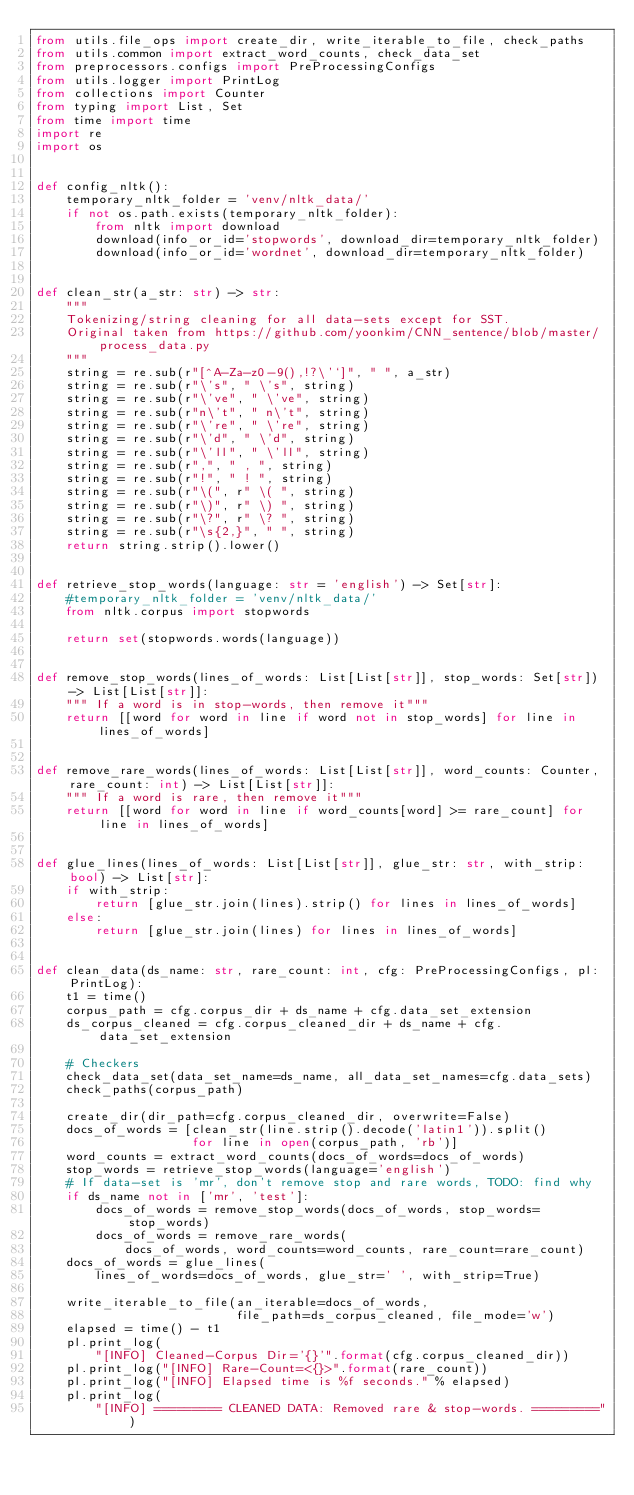Convert code to text. <code><loc_0><loc_0><loc_500><loc_500><_Python_>from utils.file_ops import create_dir, write_iterable_to_file, check_paths
from utils.common import extract_word_counts, check_data_set
from preprocessors.configs import PreProcessingConfigs
from utils.logger import PrintLog
from collections import Counter
from typing import List, Set
from time import time
import re
import os


def config_nltk():
    temporary_nltk_folder = 'venv/nltk_data/'
    if not os.path.exists(temporary_nltk_folder):
        from nltk import download
        download(info_or_id='stopwords', download_dir=temporary_nltk_folder)
        download(info_or_id='wordnet', download_dir=temporary_nltk_folder)


def clean_str(a_str: str) -> str:
    """
    Tokenizing/string cleaning for all data-sets except for SST.
    Original taken from https://github.com/yoonkim/CNN_sentence/blob/master/process_data.py
    """
    string = re.sub(r"[^A-Za-z0-9(),!?\'`]", " ", a_str)
    string = re.sub(r"\'s", " \'s", string)
    string = re.sub(r"\'ve", " \'ve", string)
    string = re.sub(r"n\'t", " n\'t", string)
    string = re.sub(r"\'re", " \'re", string)
    string = re.sub(r"\'d", " \'d", string)
    string = re.sub(r"\'ll", " \'ll", string)
    string = re.sub(r",", " , ", string)
    string = re.sub(r"!", " ! ", string)
    string = re.sub(r"\(", r" \( ", string)
    string = re.sub(r"\)", r" \) ", string)
    string = re.sub(r"\?", r" \? ", string)
    string = re.sub(r"\s{2,}", " ", string)
    return string.strip().lower()


def retrieve_stop_words(language: str = 'english') -> Set[str]:
    #temporary_nltk_folder = 'venv/nltk_data/'
    from nltk.corpus import stopwords

    return set(stopwords.words(language))


def remove_stop_words(lines_of_words: List[List[str]], stop_words: Set[str]) -> List[List[str]]:
    """ If a word is in stop-words, then remove it"""
    return [[word for word in line if word not in stop_words] for line in lines_of_words]


def remove_rare_words(lines_of_words: List[List[str]], word_counts: Counter, rare_count: int) -> List[List[str]]:
    """ If a word is rare, then remove it"""
    return [[word for word in line if word_counts[word] >= rare_count] for line in lines_of_words]


def glue_lines(lines_of_words: List[List[str]], glue_str: str, with_strip: bool) -> List[str]:
    if with_strip:
        return [glue_str.join(lines).strip() for lines in lines_of_words]
    else:
        return [glue_str.join(lines) for lines in lines_of_words]


def clean_data(ds_name: str, rare_count: int, cfg: PreProcessingConfigs, pl: PrintLog):
    t1 = time()
    corpus_path = cfg.corpus_dir + ds_name + cfg.data_set_extension
    ds_corpus_cleaned = cfg.corpus_cleaned_dir + ds_name + cfg.data_set_extension

    # Checkers
    check_data_set(data_set_name=ds_name, all_data_set_names=cfg.data_sets)
    check_paths(corpus_path)

    create_dir(dir_path=cfg.corpus_cleaned_dir, overwrite=False)
    docs_of_words = [clean_str(line.strip().decode('latin1')).split()
                     for line in open(corpus_path, 'rb')]
    word_counts = extract_word_counts(docs_of_words=docs_of_words)
    stop_words = retrieve_stop_words(language='english')
    # If data-set is 'mr', don't remove stop and rare words, TODO: find why
    if ds_name not in ['mr', 'test']:
        docs_of_words = remove_stop_words(docs_of_words, stop_words=stop_words)
        docs_of_words = remove_rare_words(
            docs_of_words, word_counts=word_counts, rare_count=rare_count)
    docs_of_words = glue_lines(
        lines_of_words=docs_of_words, glue_str=' ', with_strip=True)

    write_iterable_to_file(an_iterable=docs_of_words,
                           file_path=ds_corpus_cleaned, file_mode='w')
    elapsed = time() - t1
    pl.print_log(
        "[INFO] Cleaned-Corpus Dir='{}'".format(cfg.corpus_cleaned_dir))
    pl.print_log("[INFO] Rare-Count=<{}>".format(rare_count))
    pl.print_log("[INFO] Elapsed time is %f seconds." % elapsed)
    pl.print_log(
        "[INFO] ========= CLEANED DATA: Removed rare & stop-words. =========")
</code> 